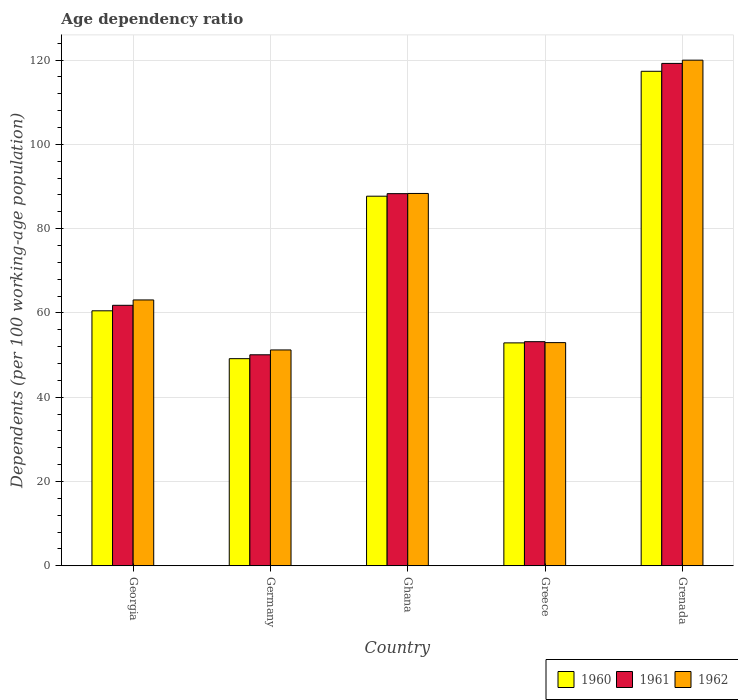How many different coloured bars are there?
Your answer should be very brief. 3. Are the number of bars per tick equal to the number of legend labels?
Offer a terse response. Yes. Are the number of bars on each tick of the X-axis equal?
Your response must be concise. Yes. How many bars are there on the 5th tick from the left?
Provide a short and direct response. 3. What is the label of the 3rd group of bars from the left?
Your answer should be compact. Ghana. In how many cases, is the number of bars for a given country not equal to the number of legend labels?
Keep it short and to the point. 0. What is the age dependency ratio in in 1962 in Greece?
Provide a succinct answer. 52.95. Across all countries, what is the maximum age dependency ratio in in 1962?
Offer a terse response. 119.96. Across all countries, what is the minimum age dependency ratio in in 1962?
Make the answer very short. 51.21. In which country was the age dependency ratio in in 1960 maximum?
Your response must be concise. Grenada. In which country was the age dependency ratio in in 1961 minimum?
Ensure brevity in your answer.  Germany. What is the total age dependency ratio in in 1962 in the graph?
Make the answer very short. 375.53. What is the difference between the age dependency ratio in in 1962 in Georgia and that in Greece?
Make the answer very short. 10.13. What is the difference between the age dependency ratio in in 1960 in Ghana and the age dependency ratio in in 1961 in Grenada?
Your answer should be compact. -31.5. What is the average age dependency ratio in in 1962 per country?
Your response must be concise. 75.11. What is the difference between the age dependency ratio in of/in 1961 and age dependency ratio in of/in 1960 in Greece?
Provide a short and direct response. 0.29. In how many countries, is the age dependency ratio in in 1962 greater than 36 %?
Offer a terse response. 5. What is the ratio of the age dependency ratio in in 1961 in Ghana to that in Greece?
Offer a terse response. 1.66. Is the difference between the age dependency ratio in in 1961 in Greece and Grenada greater than the difference between the age dependency ratio in in 1960 in Greece and Grenada?
Provide a succinct answer. No. What is the difference between the highest and the second highest age dependency ratio in in 1960?
Your response must be concise. -56.83. What is the difference between the highest and the lowest age dependency ratio in in 1962?
Your answer should be compact. 68.75. What does the 3rd bar from the left in Germany represents?
Offer a terse response. 1962. How many bars are there?
Keep it short and to the point. 15. Are all the bars in the graph horizontal?
Your answer should be compact. No. How many countries are there in the graph?
Keep it short and to the point. 5. What is the difference between two consecutive major ticks on the Y-axis?
Give a very brief answer. 20. How many legend labels are there?
Ensure brevity in your answer.  3. How are the legend labels stacked?
Offer a very short reply. Horizontal. What is the title of the graph?
Your answer should be compact. Age dependency ratio. Does "1966" appear as one of the legend labels in the graph?
Your response must be concise. No. What is the label or title of the Y-axis?
Your answer should be very brief. Dependents (per 100 working-age population). What is the Dependents (per 100 working-age population) in 1960 in Georgia?
Give a very brief answer. 60.5. What is the Dependents (per 100 working-age population) of 1961 in Georgia?
Make the answer very short. 61.8. What is the Dependents (per 100 working-age population) of 1962 in Georgia?
Your answer should be compact. 63.07. What is the Dependents (per 100 working-age population) in 1960 in Germany?
Ensure brevity in your answer.  49.14. What is the Dependents (per 100 working-age population) in 1961 in Germany?
Offer a very short reply. 50.06. What is the Dependents (per 100 working-age population) in 1962 in Germany?
Offer a very short reply. 51.21. What is the Dependents (per 100 working-age population) in 1960 in Ghana?
Offer a very short reply. 87.69. What is the Dependents (per 100 working-age population) of 1961 in Ghana?
Offer a terse response. 88.29. What is the Dependents (per 100 working-age population) of 1962 in Ghana?
Ensure brevity in your answer.  88.34. What is the Dependents (per 100 working-age population) in 1960 in Greece?
Offer a terse response. 52.88. What is the Dependents (per 100 working-age population) in 1961 in Greece?
Keep it short and to the point. 53.17. What is the Dependents (per 100 working-age population) in 1962 in Greece?
Ensure brevity in your answer.  52.95. What is the Dependents (per 100 working-age population) in 1960 in Grenada?
Your response must be concise. 117.32. What is the Dependents (per 100 working-age population) in 1961 in Grenada?
Provide a succinct answer. 119.19. What is the Dependents (per 100 working-age population) in 1962 in Grenada?
Give a very brief answer. 119.96. Across all countries, what is the maximum Dependents (per 100 working-age population) in 1960?
Ensure brevity in your answer.  117.32. Across all countries, what is the maximum Dependents (per 100 working-age population) in 1961?
Your answer should be very brief. 119.19. Across all countries, what is the maximum Dependents (per 100 working-age population) of 1962?
Your answer should be very brief. 119.96. Across all countries, what is the minimum Dependents (per 100 working-age population) in 1960?
Ensure brevity in your answer.  49.14. Across all countries, what is the minimum Dependents (per 100 working-age population) in 1961?
Provide a short and direct response. 50.06. Across all countries, what is the minimum Dependents (per 100 working-age population) in 1962?
Offer a terse response. 51.21. What is the total Dependents (per 100 working-age population) in 1960 in the graph?
Your response must be concise. 367.53. What is the total Dependents (per 100 working-age population) in 1961 in the graph?
Offer a terse response. 372.52. What is the total Dependents (per 100 working-age population) of 1962 in the graph?
Offer a terse response. 375.53. What is the difference between the Dependents (per 100 working-age population) in 1960 in Georgia and that in Germany?
Your answer should be compact. 11.36. What is the difference between the Dependents (per 100 working-age population) of 1961 in Georgia and that in Germany?
Your answer should be very brief. 11.74. What is the difference between the Dependents (per 100 working-age population) of 1962 in Georgia and that in Germany?
Offer a terse response. 11.86. What is the difference between the Dependents (per 100 working-age population) in 1960 in Georgia and that in Ghana?
Provide a short and direct response. -27.19. What is the difference between the Dependents (per 100 working-age population) in 1961 in Georgia and that in Ghana?
Ensure brevity in your answer.  -26.49. What is the difference between the Dependents (per 100 working-age population) in 1962 in Georgia and that in Ghana?
Keep it short and to the point. -25.26. What is the difference between the Dependents (per 100 working-age population) of 1960 in Georgia and that in Greece?
Give a very brief answer. 7.61. What is the difference between the Dependents (per 100 working-age population) in 1961 in Georgia and that in Greece?
Make the answer very short. 8.63. What is the difference between the Dependents (per 100 working-age population) in 1962 in Georgia and that in Greece?
Offer a very short reply. 10.13. What is the difference between the Dependents (per 100 working-age population) in 1960 in Georgia and that in Grenada?
Offer a very short reply. -56.83. What is the difference between the Dependents (per 100 working-age population) of 1961 in Georgia and that in Grenada?
Make the answer very short. -57.39. What is the difference between the Dependents (per 100 working-age population) in 1962 in Georgia and that in Grenada?
Offer a very short reply. -56.89. What is the difference between the Dependents (per 100 working-age population) of 1960 in Germany and that in Ghana?
Your response must be concise. -38.55. What is the difference between the Dependents (per 100 working-age population) in 1961 in Germany and that in Ghana?
Your answer should be very brief. -38.23. What is the difference between the Dependents (per 100 working-age population) of 1962 in Germany and that in Ghana?
Your response must be concise. -37.13. What is the difference between the Dependents (per 100 working-age population) of 1960 in Germany and that in Greece?
Provide a short and direct response. -3.74. What is the difference between the Dependents (per 100 working-age population) in 1961 in Germany and that in Greece?
Provide a short and direct response. -3.11. What is the difference between the Dependents (per 100 working-age population) of 1962 in Germany and that in Greece?
Your response must be concise. -1.74. What is the difference between the Dependents (per 100 working-age population) of 1960 in Germany and that in Grenada?
Offer a very short reply. -68.18. What is the difference between the Dependents (per 100 working-age population) of 1961 in Germany and that in Grenada?
Provide a short and direct response. -69.13. What is the difference between the Dependents (per 100 working-age population) in 1962 in Germany and that in Grenada?
Give a very brief answer. -68.75. What is the difference between the Dependents (per 100 working-age population) in 1960 in Ghana and that in Greece?
Make the answer very short. 34.8. What is the difference between the Dependents (per 100 working-age population) in 1961 in Ghana and that in Greece?
Ensure brevity in your answer.  35.12. What is the difference between the Dependents (per 100 working-age population) of 1962 in Ghana and that in Greece?
Offer a terse response. 35.39. What is the difference between the Dependents (per 100 working-age population) of 1960 in Ghana and that in Grenada?
Offer a very short reply. -29.64. What is the difference between the Dependents (per 100 working-age population) in 1961 in Ghana and that in Grenada?
Ensure brevity in your answer.  -30.9. What is the difference between the Dependents (per 100 working-age population) of 1962 in Ghana and that in Grenada?
Make the answer very short. -31.63. What is the difference between the Dependents (per 100 working-age population) in 1960 in Greece and that in Grenada?
Your response must be concise. -64.44. What is the difference between the Dependents (per 100 working-age population) of 1961 in Greece and that in Grenada?
Your response must be concise. -66.02. What is the difference between the Dependents (per 100 working-age population) of 1962 in Greece and that in Grenada?
Offer a terse response. -67.02. What is the difference between the Dependents (per 100 working-age population) in 1960 in Georgia and the Dependents (per 100 working-age population) in 1961 in Germany?
Offer a very short reply. 10.44. What is the difference between the Dependents (per 100 working-age population) in 1960 in Georgia and the Dependents (per 100 working-age population) in 1962 in Germany?
Keep it short and to the point. 9.29. What is the difference between the Dependents (per 100 working-age population) of 1961 in Georgia and the Dependents (per 100 working-age population) of 1962 in Germany?
Provide a succinct answer. 10.59. What is the difference between the Dependents (per 100 working-age population) in 1960 in Georgia and the Dependents (per 100 working-age population) in 1961 in Ghana?
Keep it short and to the point. -27.79. What is the difference between the Dependents (per 100 working-age population) of 1960 in Georgia and the Dependents (per 100 working-age population) of 1962 in Ghana?
Give a very brief answer. -27.84. What is the difference between the Dependents (per 100 working-age population) of 1961 in Georgia and the Dependents (per 100 working-age population) of 1962 in Ghana?
Offer a very short reply. -26.53. What is the difference between the Dependents (per 100 working-age population) of 1960 in Georgia and the Dependents (per 100 working-age population) of 1961 in Greece?
Provide a succinct answer. 7.33. What is the difference between the Dependents (per 100 working-age population) of 1960 in Georgia and the Dependents (per 100 working-age population) of 1962 in Greece?
Give a very brief answer. 7.55. What is the difference between the Dependents (per 100 working-age population) in 1961 in Georgia and the Dependents (per 100 working-age population) in 1962 in Greece?
Your answer should be compact. 8.86. What is the difference between the Dependents (per 100 working-age population) of 1960 in Georgia and the Dependents (per 100 working-age population) of 1961 in Grenada?
Give a very brief answer. -58.69. What is the difference between the Dependents (per 100 working-age population) in 1960 in Georgia and the Dependents (per 100 working-age population) in 1962 in Grenada?
Your answer should be compact. -59.46. What is the difference between the Dependents (per 100 working-age population) of 1961 in Georgia and the Dependents (per 100 working-age population) of 1962 in Grenada?
Provide a succinct answer. -58.16. What is the difference between the Dependents (per 100 working-age population) of 1960 in Germany and the Dependents (per 100 working-age population) of 1961 in Ghana?
Ensure brevity in your answer.  -39.15. What is the difference between the Dependents (per 100 working-age population) of 1960 in Germany and the Dependents (per 100 working-age population) of 1962 in Ghana?
Give a very brief answer. -39.2. What is the difference between the Dependents (per 100 working-age population) in 1961 in Germany and the Dependents (per 100 working-age population) in 1962 in Ghana?
Your response must be concise. -38.28. What is the difference between the Dependents (per 100 working-age population) in 1960 in Germany and the Dependents (per 100 working-age population) in 1961 in Greece?
Offer a very short reply. -4.03. What is the difference between the Dependents (per 100 working-age population) in 1960 in Germany and the Dependents (per 100 working-age population) in 1962 in Greece?
Provide a succinct answer. -3.81. What is the difference between the Dependents (per 100 working-age population) in 1961 in Germany and the Dependents (per 100 working-age population) in 1962 in Greece?
Your answer should be compact. -2.89. What is the difference between the Dependents (per 100 working-age population) of 1960 in Germany and the Dependents (per 100 working-age population) of 1961 in Grenada?
Provide a short and direct response. -70.05. What is the difference between the Dependents (per 100 working-age population) in 1960 in Germany and the Dependents (per 100 working-age population) in 1962 in Grenada?
Make the answer very short. -70.82. What is the difference between the Dependents (per 100 working-age population) in 1961 in Germany and the Dependents (per 100 working-age population) in 1962 in Grenada?
Give a very brief answer. -69.9. What is the difference between the Dependents (per 100 working-age population) in 1960 in Ghana and the Dependents (per 100 working-age population) in 1961 in Greece?
Keep it short and to the point. 34.52. What is the difference between the Dependents (per 100 working-age population) of 1960 in Ghana and the Dependents (per 100 working-age population) of 1962 in Greece?
Your answer should be very brief. 34.74. What is the difference between the Dependents (per 100 working-age population) of 1961 in Ghana and the Dependents (per 100 working-age population) of 1962 in Greece?
Offer a terse response. 35.35. What is the difference between the Dependents (per 100 working-age population) of 1960 in Ghana and the Dependents (per 100 working-age population) of 1961 in Grenada?
Offer a terse response. -31.5. What is the difference between the Dependents (per 100 working-age population) in 1960 in Ghana and the Dependents (per 100 working-age population) in 1962 in Grenada?
Provide a short and direct response. -32.27. What is the difference between the Dependents (per 100 working-age population) of 1961 in Ghana and the Dependents (per 100 working-age population) of 1962 in Grenada?
Your answer should be very brief. -31.67. What is the difference between the Dependents (per 100 working-age population) of 1960 in Greece and the Dependents (per 100 working-age population) of 1961 in Grenada?
Provide a succinct answer. -66.31. What is the difference between the Dependents (per 100 working-age population) of 1960 in Greece and the Dependents (per 100 working-age population) of 1962 in Grenada?
Your answer should be very brief. -67.08. What is the difference between the Dependents (per 100 working-age population) of 1961 in Greece and the Dependents (per 100 working-age population) of 1962 in Grenada?
Provide a short and direct response. -66.79. What is the average Dependents (per 100 working-age population) of 1960 per country?
Your answer should be very brief. 73.51. What is the average Dependents (per 100 working-age population) of 1961 per country?
Provide a short and direct response. 74.5. What is the average Dependents (per 100 working-age population) in 1962 per country?
Offer a terse response. 75.11. What is the difference between the Dependents (per 100 working-age population) of 1960 and Dependents (per 100 working-age population) of 1961 in Georgia?
Ensure brevity in your answer.  -1.3. What is the difference between the Dependents (per 100 working-age population) of 1960 and Dependents (per 100 working-age population) of 1962 in Georgia?
Ensure brevity in your answer.  -2.58. What is the difference between the Dependents (per 100 working-age population) of 1961 and Dependents (per 100 working-age population) of 1962 in Georgia?
Make the answer very short. -1.27. What is the difference between the Dependents (per 100 working-age population) in 1960 and Dependents (per 100 working-age population) in 1961 in Germany?
Offer a terse response. -0.92. What is the difference between the Dependents (per 100 working-age population) of 1960 and Dependents (per 100 working-age population) of 1962 in Germany?
Offer a very short reply. -2.07. What is the difference between the Dependents (per 100 working-age population) of 1961 and Dependents (per 100 working-age population) of 1962 in Germany?
Give a very brief answer. -1.15. What is the difference between the Dependents (per 100 working-age population) of 1960 and Dependents (per 100 working-age population) of 1961 in Ghana?
Your answer should be very brief. -0.6. What is the difference between the Dependents (per 100 working-age population) in 1960 and Dependents (per 100 working-age population) in 1962 in Ghana?
Offer a very short reply. -0.65. What is the difference between the Dependents (per 100 working-age population) in 1961 and Dependents (per 100 working-age population) in 1962 in Ghana?
Make the answer very short. -0.04. What is the difference between the Dependents (per 100 working-age population) of 1960 and Dependents (per 100 working-age population) of 1961 in Greece?
Your answer should be very brief. -0.29. What is the difference between the Dependents (per 100 working-age population) of 1960 and Dependents (per 100 working-age population) of 1962 in Greece?
Provide a short and direct response. -0.06. What is the difference between the Dependents (per 100 working-age population) of 1961 and Dependents (per 100 working-age population) of 1962 in Greece?
Give a very brief answer. 0.23. What is the difference between the Dependents (per 100 working-age population) of 1960 and Dependents (per 100 working-age population) of 1961 in Grenada?
Provide a short and direct response. -1.87. What is the difference between the Dependents (per 100 working-age population) of 1960 and Dependents (per 100 working-age population) of 1962 in Grenada?
Offer a terse response. -2.64. What is the difference between the Dependents (per 100 working-age population) of 1961 and Dependents (per 100 working-age population) of 1962 in Grenada?
Give a very brief answer. -0.77. What is the ratio of the Dependents (per 100 working-age population) of 1960 in Georgia to that in Germany?
Your answer should be compact. 1.23. What is the ratio of the Dependents (per 100 working-age population) of 1961 in Georgia to that in Germany?
Offer a terse response. 1.23. What is the ratio of the Dependents (per 100 working-age population) in 1962 in Georgia to that in Germany?
Your answer should be compact. 1.23. What is the ratio of the Dependents (per 100 working-age population) in 1960 in Georgia to that in Ghana?
Your answer should be compact. 0.69. What is the ratio of the Dependents (per 100 working-age population) in 1961 in Georgia to that in Ghana?
Provide a succinct answer. 0.7. What is the ratio of the Dependents (per 100 working-age population) of 1962 in Georgia to that in Ghana?
Keep it short and to the point. 0.71. What is the ratio of the Dependents (per 100 working-age population) in 1960 in Georgia to that in Greece?
Make the answer very short. 1.14. What is the ratio of the Dependents (per 100 working-age population) in 1961 in Georgia to that in Greece?
Offer a terse response. 1.16. What is the ratio of the Dependents (per 100 working-age population) of 1962 in Georgia to that in Greece?
Ensure brevity in your answer.  1.19. What is the ratio of the Dependents (per 100 working-age population) in 1960 in Georgia to that in Grenada?
Ensure brevity in your answer.  0.52. What is the ratio of the Dependents (per 100 working-age population) of 1961 in Georgia to that in Grenada?
Keep it short and to the point. 0.52. What is the ratio of the Dependents (per 100 working-age population) of 1962 in Georgia to that in Grenada?
Your answer should be compact. 0.53. What is the ratio of the Dependents (per 100 working-age population) in 1960 in Germany to that in Ghana?
Offer a terse response. 0.56. What is the ratio of the Dependents (per 100 working-age population) in 1961 in Germany to that in Ghana?
Your answer should be very brief. 0.57. What is the ratio of the Dependents (per 100 working-age population) in 1962 in Germany to that in Ghana?
Provide a short and direct response. 0.58. What is the ratio of the Dependents (per 100 working-age population) in 1960 in Germany to that in Greece?
Keep it short and to the point. 0.93. What is the ratio of the Dependents (per 100 working-age population) of 1961 in Germany to that in Greece?
Keep it short and to the point. 0.94. What is the ratio of the Dependents (per 100 working-age population) of 1962 in Germany to that in Greece?
Your answer should be compact. 0.97. What is the ratio of the Dependents (per 100 working-age population) in 1960 in Germany to that in Grenada?
Give a very brief answer. 0.42. What is the ratio of the Dependents (per 100 working-age population) in 1961 in Germany to that in Grenada?
Your answer should be very brief. 0.42. What is the ratio of the Dependents (per 100 working-age population) of 1962 in Germany to that in Grenada?
Keep it short and to the point. 0.43. What is the ratio of the Dependents (per 100 working-age population) in 1960 in Ghana to that in Greece?
Offer a very short reply. 1.66. What is the ratio of the Dependents (per 100 working-age population) in 1961 in Ghana to that in Greece?
Give a very brief answer. 1.66. What is the ratio of the Dependents (per 100 working-age population) of 1962 in Ghana to that in Greece?
Offer a very short reply. 1.67. What is the ratio of the Dependents (per 100 working-age population) in 1960 in Ghana to that in Grenada?
Offer a very short reply. 0.75. What is the ratio of the Dependents (per 100 working-age population) of 1961 in Ghana to that in Grenada?
Ensure brevity in your answer.  0.74. What is the ratio of the Dependents (per 100 working-age population) in 1962 in Ghana to that in Grenada?
Make the answer very short. 0.74. What is the ratio of the Dependents (per 100 working-age population) in 1960 in Greece to that in Grenada?
Ensure brevity in your answer.  0.45. What is the ratio of the Dependents (per 100 working-age population) in 1961 in Greece to that in Grenada?
Offer a very short reply. 0.45. What is the ratio of the Dependents (per 100 working-age population) in 1962 in Greece to that in Grenada?
Provide a short and direct response. 0.44. What is the difference between the highest and the second highest Dependents (per 100 working-age population) of 1960?
Offer a very short reply. 29.64. What is the difference between the highest and the second highest Dependents (per 100 working-age population) of 1961?
Provide a short and direct response. 30.9. What is the difference between the highest and the second highest Dependents (per 100 working-age population) in 1962?
Offer a terse response. 31.63. What is the difference between the highest and the lowest Dependents (per 100 working-age population) of 1960?
Your answer should be compact. 68.18. What is the difference between the highest and the lowest Dependents (per 100 working-age population) of 1961?
Give a very brief answer. 69.13. What is the difference between the highest and the lowest Dependents (per 100 working-age population) of 1962?
Your answer should be very brief. 68.75. 